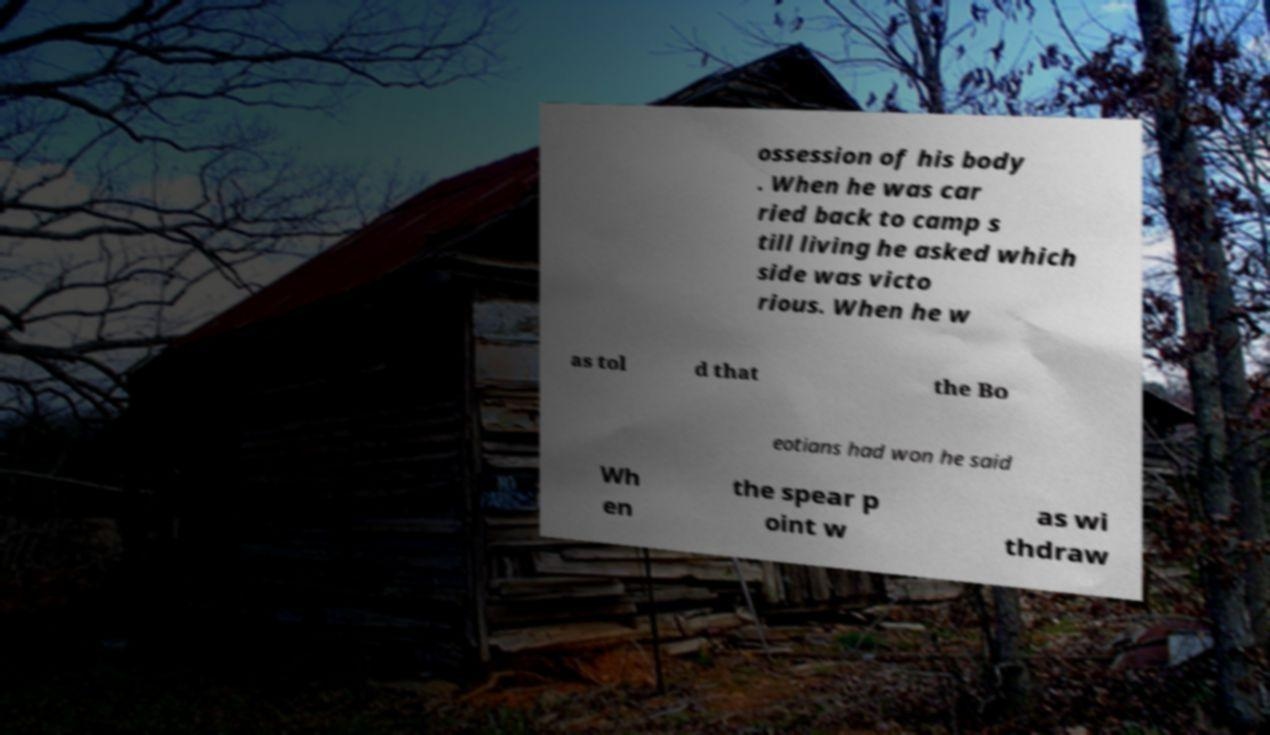Could you assist in decoding the text presented in this image and type it out clearly? ossession of his body . When he was car ried back to camp s till living he asked which side was victo rious. When he w as tol d that the Bo eotians had won he said Wh en the spear p oint w as wi thdraw 